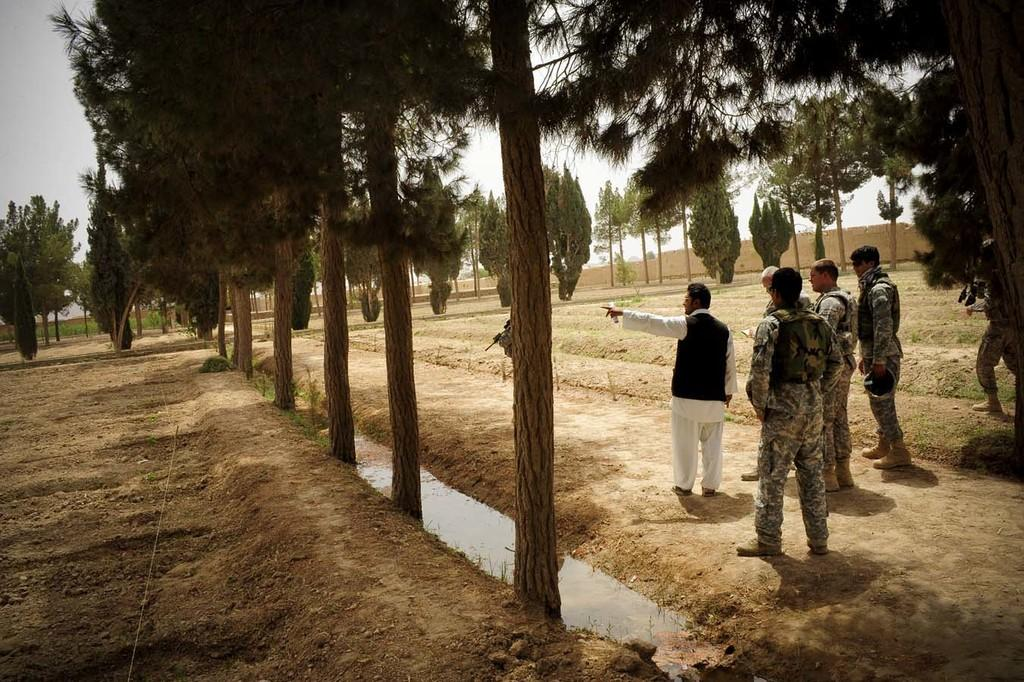How many people are in the image? There is a group of people standing in the image. What can be seen in the image besides the people? There are trees in the image. What is visible in the background of the image? The sky is visible in the background of the image. Can you see a receipt in the hands of any of the people in the image? There is no mention of a receipt in the image, so it cannot be determined if any of the people are holding one. 